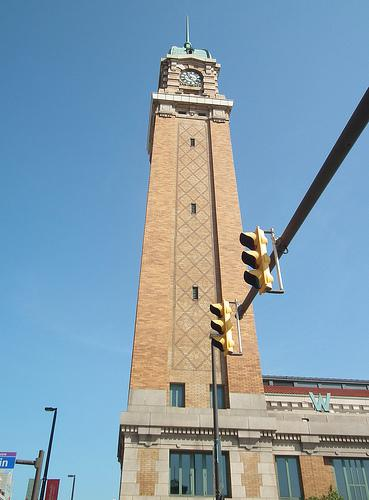Question: how many clocks can be seen?
Choices:
A. Two.
B. One.
C. Three.
D. Four.
Answer with the letter. Answer: B Question: what is the main focus of this photo?
Choices:
A. The house.
B. The tower.
C. The sky.
D. The airplane.
Answer with the letter. Answer: B Question: what is the color of the sky?
Choices:
A. Blue.
B. Orange.
C. Pink.
D. Purple.
Answer with the letter. Answer: A Question: what is the color of the tower's roof?
Choices:
A. Gray.
B. Green.
C. Black.
D. Gold.
Answer with the letter. Answer: B Question: what letter can be seen on the building?
Choices:
A. M.
B. N.
C. V.
D. W.
Answer with the letter. Answer: D Question: what building material is used for construction of the tower?
Choices:
A. Bricks.
B. Wood.
C. Metal.
D. Glass.
Answer with the letter. Answer: A Question: how many traffic lights can be seen?
Choices:
A. Three.
B. Four.
C. Two.
D. Five.
Answer with the letter. Answer: C 